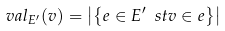Convert formula to latex. <formula><loc_0><loc_0><loc_500><loc_500>\ v a l _ { E ^ { \prime } } ( v ) = \left | \left \{ e \in { E ^ { \prime } } \ s t v \in e \right \} \right |</formula> 